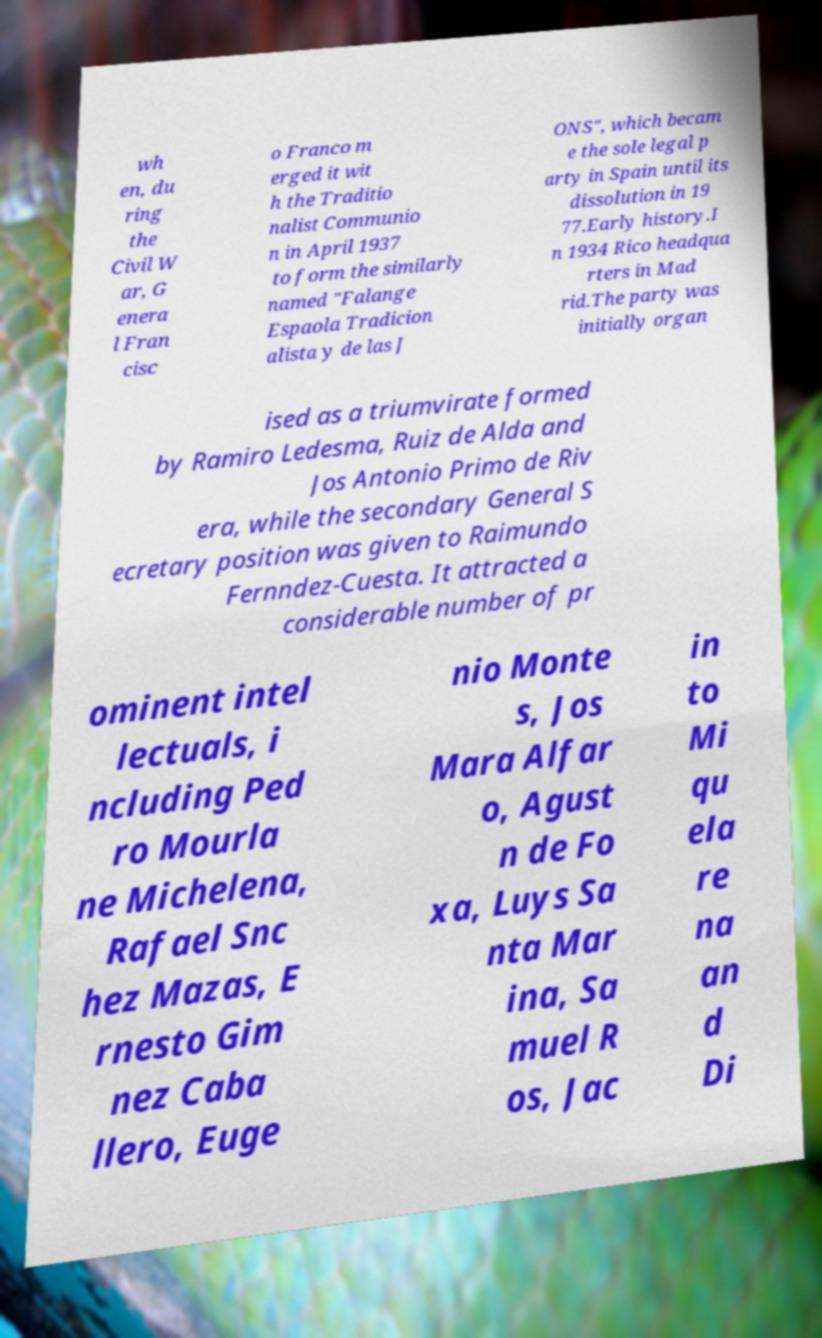There's text embedded in this image that I need extracted. Can you transcribe it verbatim? wh en, du ring the Civil W ar, G enera l Fran cisc o Franco m erged it wit h the Traditio nalist Communio n in April 1937 to form the similarly named "Falange Espaola Tradicion alista y de las J ONS", which becam e the sole legal p arty in Spain until its dissolution in 19 77.Early history.I n 1934 Rico headqua rters in Mad rid.The party was initially organ ised as a triumvirate formed by Ramiro Ledesma, Ruiz de Alda and Jos Antonio Primo de Riv era, while the secondary General S ecretary position was given to Raimundo Fernndez-Cuesta. It attracted a considerable number of pr ominent intel lectuals, i ncluding Ped ro Mourla ne Michelena, Rafael Snc hez Mazas, E rnesto Gim nez Caba llero, Euge nio Monte s, Jos Mara Alfar o, Agust n de Fo xa, Luys Sa nta Mar ina, Sa muel R os, Jac in to Mi qu ela re na an d Di 